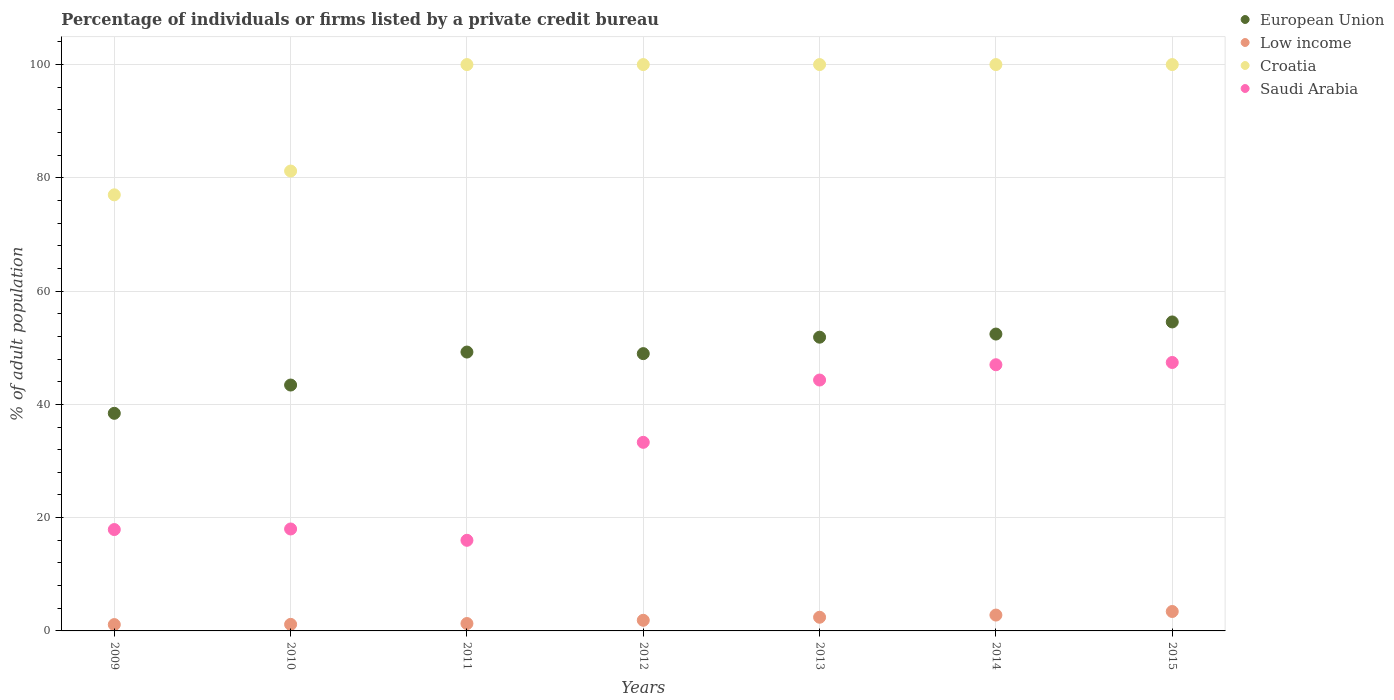What is the percentage of population listed by a private credit bureau in Low income in 2012?
Give a very brief answer. 1.88. Across all years, what is the maximum percentage of population listed by a private credit bureau in European Union?
Your answer should be compact. 54.56. Across all years, what is the minimum percentage of population listed by a private credit bureau in Croatia?
Your response must be concise. 77. In which year was the percentage of population listed by a private credit bureau in Low income maximum?
Your answer should be compact. 2015. What is the total percentage of population listed by a private credit bureau in Low income in the graph?
Keep it short and to the point. 14.1. What is the difference between the percentage of population listed by a private credit bureau in Croatia in 2010 and that in 2012?
Offer a terse response. -18.8. What is the difference between the percentage of population listed by a private credit bureau in European Union in 2013 and the percentage of population listed by a private credit bureau in Saudi Arabia in 2012?
Your answer should be very brief. 18.56. What is the average percentage of population listed by a private credit bureau in Low income per year?
Offer a terse response. 2.01. In the year 2012, what is the difference between the percentage of population listed by a private credit bureau in European Union and percentage of population listed by a private credit bureau in Low income?
Give a very brief answer. 47.08. What is the ratio of the percentage of population listed by a private credit bureau in Croatia in 2009 to that in 2015?
Offer a terse response. 0.77. Is the percentage of population listed by a private credit bureau in Croatia in 2009 less than that in 2013?
Provide a short and direct response. Yes. Is the difference between the percentage of population listed by a private credit bureau in European Union in 2010 and 2011 greater than the difference between the percentage of population listed by a private credit bureau in Low income in 2010 and 2011?
Ensure brevity in your answer.  No. What is the difference between the highest and the lowest percentage of population listed by a private credit bureau in European Union?
Provide a succinct answer. 16.13. In how many years, is the percentage of population listed by a private credit bureau in Saudi Arabia greater than the average percentage of population listed by a private credit bureau in Saudi Arabia taken over all years?
Offer a very short reply. 4. Is the sum of the percentage of population listed by a private credit bureau in Low income in 2009 and 2013 greater than the maximum percentage of population listed by a private credit bureau in European Union across all years?
Give a very brief answer. No. Is it the case that in every year, the sum of the percentage of population listed by a private credit bureau in Croatia and percentage of population listed by a private credit bureau in Low income  is greater than the sum of percentage of population listed by a private credit bureau in Saudi Arabia and percentage of population listed by a private credit bureau in European Union?
Offer a terse response. Yes. Does the percentage of population listed by a private credit bureau in Low income monotonically increase over the years?
Make the answer very short. Yes. Is the percentage of population listed by a private credit bureau in European Union strictly less than the percentage of population listed by a private credit bureau in Croatia over the years?
Ensure brevity in your answer.  Yes. How many legend labels are there?
Provide a short and direct response. 4. How are the legend labels stacked?
Provide a short and direct response. Vertical. What is the title of the graph?
Give a very brief answer. Percentage of individuals or firms listed by a private credit bureau. What is the label or title of the Y-axis?
Your answer should be compact. % of adult population. What is the % of adult population of European Union in 2009?
Give a very brief answer. 38.42. What is the % of adult population of Low income in 2009?
Offer a terse response. 1.12. What is the % of adult population of Croatia in 2009?
Give a very brief answer. 77. What is the % of adult population of Saudi Arabia in 2009?
Your answer should be compact. 17.9. What is the % of adult population of European Union in 2010?
Provide a short and direct response. 43.41. What is the % of adult population in Low income in 2010?
Offer a terse response. 1.16. What is the % of adult population of Croatia in 2010?
Your answer should be compact. 81.2. What is the % of adult population of Saudi Arabia in 2010?
Offer a very short reply. 18. What is the % of adult population in European Union in 2011?
Offer a terse response. 49.24. What is the % of adult population in Low income in 2011?
Make the answer very short. 1.3. What is the % of adult population of Saudi Arabia in 2011?
Make the answer very short. 16. What is the % of adult population in European Union in 2012?
Your answer should be compact. 48.96. What is the % of adult population in Low income in 2012?
Give a very brief answer. 1.88. What is the % of adult population of Saudi Arabia in 2012?
Your response must be concise. 33.3. What is the % of adult population of European Union in 2013?
Offer a very short reply. 51.86. What is the % of adult population in Low income in 2013?
Provide a succinct answer. 2.41. What is the % of adult population in Saudi Arabia in 2013?
Offer a terse response. 44.3. What is the % of adult population in European Union in 2014?
Ensure brevity in your answer.  52.42. What is the % of adult population in Low income in 2014?
Ensure brevity in your answer.  2.8. What is the % of adult population of Croatia in 2014?
Keep it short and to the point. 100. What is the % of adult population in Saudi Arabia in 2014?
Ensure brevity in your answer.  47. What is the % of adult population in European Union in 2015?
Offer a very short reply. 54.56. What is the % of adult population in Low income in 2015?
Your response must be concise. 3.43. What is the % of adult population in Croatia in 2015?
Make the answer very short. 100. What is the % of adult population of Saudi Arabia in 2015?
Keep it short and to the point. 47.4. Across all years, what is the maximum % of adult population in European Union?
Your answer should be very brief. 54.56. Across all years, what is the maximum % of adult population of Low income?
Provide a short and direct response. 3.43. Across all years, what is the maximum % of adult population of Saudi Arabia?
Ensure brevity in your answer.  47.4. Across all years, what is the minimum % of adult population in European Union?
Provide a succinct answer. 38.42. Across all years, what is the minimum % of adult population in Low income?
Provide a short and direct response. 1.12. Across all years, what is the minimum % of adult population in Croatia?
Provide a short and direct response. 77. What is the total % of adult population in European Union in the graph?
Keep it short and to the point. 338.88. What is the total % of adult population of Low income in the graph?
Offer a very short reply. 14.1. What is the total % of adult population in Croatia in the graph?
Ensure brevity in your answer.  658.2. What is the total % of adult population in Saudi Arabia in the graph?
Give a very brief answer. 223.9. What is the difference between the % of adult population in European Union in 2009 and that in 2010?
Offer a terse response. -4.99. What is the difference between the % of adult population in Low income in 2009 and that in 2010?
Offer a terse response. -0.04. What is the difference between the % of adult population in Croatia in 2009 and that in 2010?
Offer a very short reply. -4.2. What is the difference between the % of adult population of European Union in 2009 and that in 2011?
Your answer should be very brief. -10.82. What is the difference between the % of adult population in Low income in 2009 and that in 2011?
Offer a very short reply. -0.19. What is the difference between the % of adult population in Saudi Arabia in 2009 and that in 2011?
Offer a very short reply. 1.9. What is the difference between the % of adult population of European Union in 2009 and that in 2012?
Your answer should be very brief. -10.54. What is the difference between the % of adult population of Low income in 2009 and that in 2012?
Your response must be concise. -0.76. What is the difference between the % of adult population of Saudi Arabia in 2009 and that in 2012?
Your response must be concise. -15.4. What is the difference between the % of adult population of European Union in 2009 and that in 2013?
Provide a succinct answer. -13.44. What is the difference between the % of adult population of Low income in 2009 and that in 2013?
Your answer should be very brief. -1.3. What is the difference between the % of adult population of Croatia in 2009 and that in 2013?
Provide a short and direct response. -23. What is the difference between the % of adult population in Saudi Arabia in 2009 and that in 2013?
Offer a very short reply. -26.4. What is the difference between the % of adult population of European Union in 2009 and that in 2014?
Offer a terse response. -14. What is the difference between the % of adult population of Low income in 2009 and that in 2014?
Offer a terse response. -1.68. What is the difference between the % of adult population of Saudi Arabia in 2009 and that in 2014?
Offer a terse response. -29.1. What is the difference between the % of adult population in European Union in 2009 and that in 2015?
Give a very brief answer. -16.13. What is the difference between the % of adult population in Low income in 2009 and that in 2015?
Ensure brevity in your answer.  -2.31. What is the difference between the % of adult population in Croatia in 2009 and that in 2015?
Provide a short and direct response. -23. What is the difference between the % of adult population of Saudi Arabia in 2009 and that in 2015?
Your response must be concise. -29.5. What is the difference between the % of adult population of European Union in 2010 and that in 2011?
Offer a terse response. -5.82. What is the difference between the % of adult population of Low income in 2010 and that in 2011?
Ensure brevity in your answer.  -0.15. What is the difference between the % of adult population of Croatia in 2010 and that in 2011?
Your response must be concise. -18.8. What is the difference between the % of adult population in European Union in 2010 and that in 2012?
Your answer should be compact. -5.55. What is the difference between the % of adult population of Low income in 2010 and that in 2012?
Offer a very short reply. -0.72. What is the difference between the % of adult population in Croatia in 2010 and that in 2012?
Your answer should be very brief. -18.8. What is the difference between the % of adult population in Saudi Arabia in 2010 and that in 2012?
Provide a succinct answer. -15.3. What is the difference between the % of adult population of European Union in 2010 and that in 2013?
Your response must be concise. -8.45. What is the difference between the % of adult population in Low income in 2010 and that in 2013?
Offer a terse response. -1.26. What is the difference between the % of adult population in Croatia in 2010 and that in 2013?
Ensure brevity in your answer.  -18.8. What is the difference between the % of adult population of Saudi Arabia in 2010 and that in 2013?
Ensure brevity in your answer.  -26.3. What is the difference between the % of adult population in European Union in 2010 and that in 2014?
Offer a very short reply. -9. What is the difference between the % of adult population of Low income in 2010 and that in 2014?
Give a very brief answer. -1.64. What is the difference between the % of adult population of Croatia in 2010 and that in 2014?
Give a very brief answer. -18.8. What is the difference between the % of adult population in European Union in 2010 and that in 2015?
Ensure brevity in your answer.  -11.14. What is the difference between the % of adult population of Low income in 2010 and that in 2015?
Your response must be concise. -2.27. What is the difference between the % of adult population in Croatia in 2010 and that in 2015?
Provide a succinct answer. -18.8. What is the difference between the % of adult population of Saudi Arabia in 2010 and that in 2015?
Offer a terse response. -29.4. What is the difference between the % of adult population of European Union in 2011 and that in 2012?
Provide a succinct answer. 0.28. What is the difference between the % of adult population in Low income in 2011 and that in 2012?
Offer a terse response. -0.57. What is the difference between the % of adult population in Croatia in 2011 and that in 2012?
Offer a terse response. 0. What is the difference between the % of adult population of Saudi Arabia in 2011 and that in 2012?
Your response must be concise. -17.3. What is the difference between the % of adult population of European Union in 2011 and that in 2013?
Your answer should be very brief. -2.62. What is the difference between the % of adult population in Low income in 2011 and that in 2013?
Ensure brevity in your answer.  -1.11. What is the difference between the % of adult population in Croatia in 2011 and that in 2013?
Offer a very short reply. 0. What is the difference between the % of adult population in Saudi Arabia in 2011 and that in 2013?
Provide a short and direct response. -28.3. What is the difference between the % of adult population in European Union in 2011 and that in 2014?
Keep it short and to the point. -3.18. What is the difference between the % of adult population of Low income in 2011 and that in 2014?
Keep it short and to the point. -1.5. What is the difference between the % of adult population in Croatia in 2011 and that in 2014?
Give a very brief answer. 0. What is the difference between the % of adult population in Saudi Arabia in 2011 and that in 2014?
Provide a short and direct response. -31. What is the difference between the % of adult population of European Union in 2011 and that in 2015?
Keep it short and to the point. -5.32. What is the difference between the % of adult population in Low income in 2011 and that in 2015?
Make the answer very short. -2.13. What is the difference between the % of adult population in Saudi Arabia in 2011 and that in 2015?
Keep it short and to the point. -31.4. What is the difference between the % of adult population of European Union in 2012 and that in 2013?
Offer a terse response. -2.9. What is the difference between the % of adult population in Low income in 2012 and that in 2013?
Give a very brief answer. -0.54. What is the difference between the % of adult population in Croatia in 2012 and that in 2013?
Provide a succinct answer. 0. What is the difference between the % of adult population of European Union in 2012 and that in 2014?
Keep it short and to the point. -3.46. What is the difference between the % of adult population of Low income in 2012 and that in 2014?
Provide a succinct answer. -0.92. What is the difference between the % of adult population in Croatia in 2012 and that in 2014?
Your response must be concise. 0. What is the difference between the % of adult population in Saudi Arabia in 2012 and that in 2014?
Make the answer very short. -13.7. What is the difference between the % of adult population of European Union in 2012 and that in 2015?
Ensure brevity in your answer.  -5.6. What is the difference between the % of adult population of Low income in 2012 and that in 2015?
Offer a very short reply. -1.55. What is the difference between the % of adult population in Saudi Arabia in 2012 and that in 2015?
Your answer should be very brief. -14.1. What is the difference between the % of adult population in European Union in 2013 and that in 2014?
Ensure brevity in your answer.  -0.55. What is the difference between the % of adult population in Low income in 2013 and that in 2014?
Make the answer very short. -0.39. What is the difference between the % of adult population in Croatia in 2013 and that in 2014?
Provide a short and direct response. 0. What is the difference between the % of adult population in Saudi Arabia in 2013 and that in 2014?
Your response must be concise. -2.7. What is the difference between the % of adult population of European Union in 2013 and that in 2015?
Your answer should be very brief. -2.69. What is the difference between the % of adult population of Low income in 2013 and that in 2015?
Your answer should be very brief. -1.02. What is the difference between the % of adult population of Saudi Arabia in 2013 and that in 2015?
Your answer should be very brief. -3.1. What is the difference between the % of adult population in European Union in 2014 and that in 2015?
Your answer should be compact. -2.14. What is the difference between the % of adult population in Low income in 2014 and that in 2015?
Give a very brief answer. -0.63. What is the difference between the % of adult population in European Union in 2009 and the % of adult population in Low income in 2010?
Your answer should be compact. 37.27. What is the difference between the % of adult population in European Union in 2009 and the % of adult population in Croatia in 2010?
Keep it short and to the point. -42.78. What is the difference between the % of adult population of European Union in 2009 and the % of adult population of Saudi Arabia in 2010?
Offer a terse response. 20.42. What is the difference between the % of adult population of Low income in 2009 and the % of adult population of Croatia in 2010?
Your answer should be compact. -80.08. What is the difference between the % of adult population in Low income in 2009 and the % of adult population in Saudi Arabia in 2010?
Your response must be concise. -16.88. What is the difference between the % of adult population of European Union in 2009 and the % of adult population of Low income in 2011?
Give a very brief answer. 37.12. What is the difference between the % of adult population in European Union in 2009 and the % of adult population in Croatia in 2011?
Ensure brevity in your answer.  -61.58. What is the difference between the % of adult population in European Union in 2009 and the % of adult population in Saudi Arabia in 2011?
Your answer should be compact. 22.42. What is the difference between the % of adult population of Low income in 2009 and the % of adult population of Croatia in 2011?
Make the answer very short. -98.88. What is the difference between the % of adult population in Low income in 2009 and the % of adult population in Saudi Arabia in 2011?
Make the answer very short. -14.88. What is the difference between the % of adult population in Croatia in 2009 and the % of adult population in Saudi Arabia in 2011?
Keep it short and to the point. 61. What is the difference between the % of adult population of European Union in 2009 and the % of adult population of Low income in 2012?
Provide a short and direct response. 36.55. What is the difference between the % of adult population of European Union in 2009 and the % of adult population of Croatia in 2012?
Your answer should be very brief. -61.58. What is the difference between the % of adult population in European Union in 2009 and the % of adult population in Saudi Arabia in 2012?
Your answer should be compact. 5.12. What is the difference between the % of adult population of Low income in 2009 and the % of adult population of Croatia in 2012?
Your answer should be very brief. -98.88. What is the difference between the % of adult population in Low income in 2009 and the % of adult population in Saudi Arabia in 2012?
Your answer should be very brief. -32.18. What is the difference between the % of adult population in Croatia in 2009 and the % of adult population in Saudi Arabia in 2012?
Provide a succinct answer. 43.7. What is the difference between the % of adult population of European Union in 2009 and the % of adult population of Low income in 2013?
Provide a succinct answer. 36.01. What is the difference between the % of adult population of European Union in 2009 and the % of adult population of Croatia in 2013?
Give a very brief answer. -61.58. What is the difference between the % of adult population of European Union in 2009 and the % of adult population of Saudi Arabia in 2013?
Your answer should be very brief. -5.88. What is the difference between the % of adult population of Low income in 2009 and the % of adult population of Croatia in 2013?
Provide a succinct answer. -98.88. What is the difference between the % of adult population in Low income in 2009 and the % of adult population in Saudi Arabia in 2013?
Offer a terse response. -43.18. What is the difference between the % of adult population in Croatia in 2009 and the % of adult population in Saudi Arabia in 2013?
Ensure brevity in your answer.  32.7. What is the difference between the % of adult population of European Union in 2009 and the % of adult population of Low income in 2014?
Your answer should be compact. 35.62. What is the difference between the % of adult population in European Union in 2009 and the % of adult population in Croatia in 2014?
Provide a succinct answer. -61.58. What is the difference between the % of adult population of European Union in 2009 and the % of adult population of Saudi Arabia in 2014?
Offer a very short reply. -8.58. What is the difference between the % of adult population of Low income in 2009 and the % of adult population of Croatia in 2014?
Offer a terse response. -98.88. What is the difference between the % of adult population in Low income in 2009 and the % of adult population in Saudi Arabia in 2014?
Your answer should be very brief. -45.88. What is the difference between the % of adult population of European Union in 2009 and the % of adult population of Low income in 2015?
Your answer should be compact. 34.99. What is the difference between the % of adult population of European Union in 2009 and the % of adult population of Croatia in 2015?
Offer a very short reply. -61.58. What is the difference between the % of adult population of European Union in 2009 and the % of adult population of Saudi Arabia in 2015?
Provide a succinct answer. -8.98. What is the difference between the % of adult population of Low income in 2009 and the % of adult population of Croatia in 2015?
Provide a succinct answer. -98.88. What is the difference between the % of adult population of Low income in 2009 and the % of adult population of Saudi Arabia in 2015?
Offer a very short reply. -46.28. What is the difference between the % of adult population in Croatia in 2009 and the % of adult population in Saudi Arabia in 2015?
Give a very brief answer. 29.6. What is the difference between the % of adult population of European Union in 2010 and the % of adult population of Low income in 2011?
Your response must be concise. 42.11. What is the difference between the % of adult population in European Union in 2010 and the % of adult population in Croatia in 2011?
Provide a succinct answer. -56.59. What is the difference between the % of adult population of European Union in 2010 and the % of adult population of Saudi Arabia in 2011?
Ensure brevity in your answer.  27.41. What is the difference between the % of adult population in Low income in 2010 and the % of adult population in Croatia in 2011?
Offer a very short reply. -98.84. What is the difference between the % of adult population in Low income in 2010 and the % of adult population in Saudi Arabia in 2011?
Provide a succinct answer. -14.84. What is the difference between the % of adult population of Croatia in 2010 and the % of adult population of Saudi Arabia in 2011?
Your response must be concise. 65.2. What is the difference between the % of adult population in European Union in 2010 and the % of adult population in Low income in 2012?
Provide a succinct answer. 41.54. What is the difference between the % of adult population of European Union in 2010 and the % of adult population of Croatia in 2012?
Provide a succinct answer. -56.59. What is the difference between the % of adult population of European Union in 2010 and the % of adult population of Saudi Arabia in 2012?
Your answer should be very brief. 10.11. What is the difference between the % of adult population of Low income in 2010 and the % of adult population of Croatia in 2012?
Offer a terse response. -98.84. What is the difference between the % of adult population in Low income in 2010 and the % of adult population in Saudi Arabia in 2012?
Provide a short and direct response. -32.14. What is the difference between the % of adult population of Croatia in 2010 and the % of adult population of Saudi Arabia in 2012?
Provide a short and direct response. 47.9. What is the difference between the % of adult population of European Union in 2010 and the % of adult population of Low income in 2013?
Your answer should be very brief. 41. What is the difference between the % of adult population in European Union in 2010 and the % of adult population in Croatia in 2013?
Your answer should be compact. -56.59. What is the difference between the % of adult population of European Union in 2010 and the % of adult population of Saudi Arabia in 2013?
Ensure brevity in your answer.  -0.89. What is the difference between the % of adult population of Low income in 2010 and the % of adult population of Croatia in 2013?
Your answer should be very brief. -98.84. What is the difference between the % of adult population of Low income in 2010 and the % of adult population of Saudi Arabia in 2013?
Provide a short and direct response. -43.14. What is the difference between the % of adult population in Croatia in 2010 and the % of adult population in Saudi Arabia in 2013?
Ensure brevity in your answer.  36.9. What is the difference between the % of adult population of European Union in 2010 and the % of adult population of Low income in 2014?
Make the answer very short. 40.62. What is the difference between the % of adult population of European Union in 2010 and the % of adult population of Croatia in 2014?
Give a very brief answer. -56.59. What is the difference between the % of adult population in European Union in 2010 and the % of adult population in Saudi Arabia in 2014?
Your answer should be very brief. -3.59. What is the difference between the % of adult population of Low income in 2010 and the % of adult population of Croatia in 2014?
Offer a very short reply. -98.84. What is the difference between the % of adult population in Low income in 2010 and the % of adult population in Saudi Arabia in 2014?
Your answer should be compact. -45.84. What is the difference between the % of adult population of Croatia in 2010 and the % of adult population of Saudi Arabia in 2014?
Keep it short and to the point. 34.2. What is the difference between the % of adult population of European Union in 2010 and the % of adult population of Low income in 2015?
Keep it short and to the point. 39.98. What is the difference between the % of adult population in European Union in 2010 and the % of adult population in Croatia in 2015?
Keep it short and to the point. -56.59. What is the difference between the % of adult population in European Union in 2010 and the % of adult population in Saudi Arabia in 2015?
Give a very brief answer. -3.99. What is the difference between the % of adult population in Low income in 2010 and the % of adult population in Croatia in 2015?
Offer a terse response. -98.84. What is the difference between the % of adult population of Low income in 2010 and the % of adult population of Saudi Arabia in 2015?
Make the answer very short. -46.24. What is the difference between the % of adult population in Croatia in 2010 and the % of adult population in Saudi Arabia in 2015?
Offer a very short reply. 33.8. What is the difference between the % of adult population in European Union in 2011 and the % of adult population in Low income in 2012?
Give a very brief answer. 47.36. What is the difference between the % of adult population in European Union in 2011 and the % of adult population in Croatia in 2012?
Offer a terse response. -50.76. What is the difference between the % of adult population in European Union in 2011 and the % of adult population in Saudi Arabia in 2012?
Your answer should be very brief. 15.94. What is the difference between the % of adult population in Low income in 2011 and the % of adult population in Croatia in 2012?
Ensure brevity in your answer.  -98.7. What is the difference between the % of adult population in Low income in 2011 and the % of adult population in Saudi Arabia in 2012?
Offer a very short reply. -32. What is the difference between the % of adult population in Croatia in 2011 and the % of adult population in Saudi Arabia in 2012?
Offer a terse response. 66.7. What is the difference between the % of adult population of European Union in 2011 and the % of adult population of Low income in 2013?
Offer a terse response. 46.83. What is the difference between the % of adult population of European Union in 2011 and the % of adult population of Croatia in 2013?
Offer a very short reply. -50.76. What is the difference between the % of adult population in European Union in 2011 and the % of adult population in Saudi Arabia in 2013?
Keep it short and to the point. 4.94. What is the difference between the % of adult population in Low income in 2011 and the % of adult population in Croatia in 2013?
Offer a terse response. -98.7. What is the difference between the % of adult population in Low income in 2011 and the % of adult population in Saudi Arabia in 2013?
Offer a very short reply. -43. What is the difference between the % of adult population of Croatia in 2011 and the % of adult population of Saudi Arabia in 2013?
Your answer should be very brief. 55.7. What is the difference between the % of adult population in European Union in 2011 and the % of adult population in Low income in 2014?
Give a very brief answer. 46.44. What is the difference between the % of adult population in European Union in 2011 and the % of adult population in Croatia in 2014?
Offer a very short reply. -50.76. What is the difference between the % of adult population in European Union in 2011 and the % of adult population in Saudi Arabia in 2014?
Make the answer very short. 2.24. What is the difference between the % of adult population in Low income in 2011 and the % of adult population in Croatia in 2014?
Provide a succinct answer. -98.7. What is the difference between the % of adult population of Low income in 2011 and the % of adult population of Saudi Arabia in 2014?
Your answer should be very brief. -45.7. What is the difference between the % of adult population of Croatia in 2011 and the % of adult population of Saudi Arabia in 2014?
Ensure brevity in your answer.  53. What is the difference between the % of adult population in European Union in 2011 and the % of adult population in Low income in 2015?
Your answer should be compact. 45.81. What is the difference between the % of adult population in European Union in 2011 and the % of adult population in Croatia in 2015?
Make the answer very short. -50.76. What is the difference between the % of adult population of European Union in 2011 and the % of adult population of Saudi Arabia in 2015?
Ensure brevity in your answer.  1.84. What is the difference between the % of adult population in Low income in 2011 and the % of adult population in Croatia in 2015?
Give a very brief answer. -98.7. What is the difference between the % of adult population of Low income in 2011 and the % of adult population of Saudi Arabia in 2015?
Keep it short and to the point. -46.1. What is the difference between the % of adult population of Croatia in 2011 and the % of adult population of Saudi Arabia in 2015?
Offer a terse response. 52.6. What is the difference between the % of adult population in European Union in 2012 and the % of adult population in Low income in 2013?
Provide a succinct answer. 46.55. What is the difference between the % of adult population of European Union in 2012 and the % of adult population of Croatia in 2013?
Provide a short and direct response. -51.04. What is the difference between the % of adult population in European Union in 2012 and the % of adult population in Saudi Arabia in 2013?
Give a very brief answer. 4.66. What is the difference between the % of adult population in Low income in 2012 and the % of adult population in Croatia in 2013?
Ensure brevity in your answer.  -98.12. What is the difference between the % of adult population of Low income in 2012 and the % of adult population of Saudi Arabia in 2013?
Ensure brevity in your answer.  -42.42. What is the difference between the % of adult population in Croatia in 2012 and the % of adult population in Saudi Arabia in 2013?
Offer a very short reply. 55.7. What is the difference between the % of adult population of European Union in 2012 and the % of adult population of Low income in 2014?
Ensure brevity in your answer.  46.16. What is the difference between the % of adult population of European Union in 2012 and the % of adult population of Croatia in 2014?
Keep it short and to the point. -51.04. What is the difference between the % of adult population of European Union in 2012 and the % of adult population of Saudi Arabia in 2014?
Provide a short and direct response. 1.96. What is the difference between the % of adult population of Low income in 2012 and the % of adult population of Croatia in 2014?
Provide a succinct answer. -98.12. What is the difference between the % of adult population of Low income in 2012 and the % of adult population of Saudi Arabia in 2014?
Offer a terse response. -45.12. What is the difference between the % of adult population of European Union in 2012 and the % of adult population of Low income in 2015?
Your answer should be compact. 45.53. What is the difference between the % of adult population of European Union in 2012 and the % of adult population of Croatia in 2015?
Provide a succinct answer. -51.04. What is the difference between the % of adult population in European Union in 2012 and the % of adult population in Saudi Arabia in 2015?
Provide a succinct answer. 1.56. What is the difference between the % of adult population of Low income in 2012 and the % of adult population of Croatia in 2015?
Your response must be concise. -98.12. What is the difference between the % of adult population in Low income in 2012 and the % of adult population in Saudi Arabia in 2015?
Keep it short and to the point. -45.52. What is the difference between the % of adult population in Croatia in 2012 and the % of adult population in Saudi Arabia in 2015?
Offer a very short reply. 52.6. What is the difference between the % of adult population in European Union in 2013 and the % of adult population in Low income in 2014?
Provide a short and direct response. 49.06. What is the difference between the % of adult population in European Union in 2013 and the % of adult population in Croatia in 2014?
Give a very brief answer. -48.14. What is the difference between the % of adult population of European Union in 2013 and the % of adult population of Saudi Arabia in 2014?
Your answer should be very brief. 4.86. What is the difference between the % of adult population of Low income in 2013 and the % of adult population of Croatia in 2014?
Offer a terse response. -97.59. What is the difference between the % of adult population in Low income in 2013 and the % of adult population in Saudi Arabia in 2014?
Ensure brevity in your answer.  -44.59. What is the difference between the % of adult population in Croatia in 2013 and the % of adult population in Saudi Arabia in 2014?
Ensure brevity in your answer.  53. What is the difference between the % of adult population of European Union in 2013 and the % of adult population of Low income in 2015?
Provide a short and direct response. 48.43. What is the difference between the % of adult population in European Union in 2013 and the % of adult population in Croatia in 2015?
Your answer should be compact. -48.14. What is the difference between the % of adult population in European Union in 2013 and the % of adult population in Saudi Arabia in 2015?
Offer a terse response. 4.46. What is the difference between the % of adult population of Low income in 2013 and the % of adult population of Croatia in 2015?
Provide a short and direct response. -97.59. What is the difference between the % of adult population of Low income in 2013 and the % of adult population of Saudi Arabia in 2015?
Keep it short and to the point. -44.99. What is the difference between the % of adult population in Croatia in 2013 and the % of adult population in Saudi Arabia in 2015?
Keep it short and to the point. 52.6. What is the difference between the % of adult population of European Union in 2014 and the % of adult population of Low income in 2015?
Ensure brevity in your answer.  48.99. What is the difference between the % of adult population in European Union in 2014 and the % of adult population in Croatia in 2015?
Your response must be concise. -47.58. What is the difference between the % of adult population of European Union in 2014 and the % of adult population of Saudi Arabia in 2015?
Ensure brevity in your answer.  5.02. What is the difference between the % of adult population in Low income in 2014 and the % of adult population in Croatia in 2015?
Give a very brief answer. -97.2. What is the difference between the % of adult population of Low income in 2014 and the % of adult population of Saudi Arabia in 2015?
Offer a very short reply. -44.6. What is the difference between the % of adult population of Croatia in 2014 and the % of adult population of Saudi Arabia in 2015?
Your answer should be compact. 52.6. What is the average % of adult population in European Union per year?
Your answer should be very brief. 48.41. What is the average % of adult population in Low income per year?
Your response must be concise. 2.01. What is the average % of adult population in Croatia per year?
Give a very brief answer. 94.03. What is the average % of adult population in Saudi Arabia per year?
Your response must be concise. 31.99. In the year 2009, what is the difference between the % of adult population of European Union and % of adult population of Low income?
Your answer should be very brief. 37.3. In the year 2009, what is the difference between the % of adult population in European Union and % of adult population in Croatia?
Provide a short and direct response. -38.58. In the year 2009, what is the difference between the % of adult population of European Union and % of adult population of Saudi Arabia?
Keep it short and to the point. 20.52. In the year 2009, what is the difference between the % of adult population of Low income and % of adult population of Croatia?
Provide a succinct answer. -75.88. In the year 2009, what is the difference between the % of adult population of Low income and % of adult population of Saudi Arabia?
Give a very brief answer. -16.78. In the year 2009, what is the difference between the % of adult population in Croatia and % of adult population in Saudi Arabia?
Provide a short and direct response. 59.1. In the year 2010, what is the difference between the % of adult population in European Union and % of adult population in Low income?
Your answer should be compact. 42.26. In the year 2010, what is the difference between the % of adult population in European Union and % of adult population in Croatia?
Keep it short and to the point. -37.79. In the year 2010, what is the difference between the % of adult population in European Union and % of adult population in Saudi Arabia?
Keep it short and to the point. 25.41. In the year 2010, what is the difference between the % of adult population in Low income and % of adult population in Croatia?
Make the answer very short. -80.04. In the year 2010, what is the difference between the % of adult population of Low income and % of adult population of Saudi Arabia?
Make the answer very short. -16.84. In the year 2010, what is the difference between the % of adult population of Croatia and % of adult population of Saudi Arabia?
Offer a terse response. 63.2. In the year 2011, what is the difference between the % of adult population of European Union and % of adult population of Low income?
Offer a terse response. 47.94. In the year 2011, what is the difference between the % of adult population in European Union and % of adult population in Croatia?
Offer a very short reply. -50.76. In the year 2011, what is the difference between the % of adult population of European Union and % of adult population of Saudi Arabia?
Ensure brevity in your answer.  33.24. In the year 2011, what is the difference between the % of adult population in Low income and % of adult population in Croatia?
Ensure brevity in your answer.  -98.7. In the year 2011, what is the difference between the % of adult population of Low income and % of adult population of Saudi Arabia?
Your answer should be compact. -14.7. In the year 2012, what is the difference between the % of adult population of European Union and % of adult population of Low income?
Ensure brevity in your answer.  47.08. In the year 2012, what is the difference between the % of adult population in European Union and % of adult population in Croatia?
Offer a very short reply. -51.04. In the year 2012, what is the difference between the % of adult population in European Union and % of adult population in Saudi Arabia?
Offer a terse response. 15.66. In the year 2012, what is the difference between the % of adult population of Low income and % of adult population of Croatia?
Ensure brevity in your answer.  -98.12. In the year 2012, what is the difference between the % of adult population of Low income and % of adult population of Saudi Arabia?
Give a very brief answer. -31.42. In the year 2012, what is the difference between the % of adult population of Croatia and % of adult population of Saudi Arabia?
Offer a terse response. 66.7. In the year 2013, what is the difference between the % of adult population of European Union and % of adult population of Low income?
Ensure brevity in your answer.  49.45. In the year 2013, what is the difference between the % of adult population of European Union and % of adult population of Croatia?
Give a very brief answer. -48.14. In the year 2013, what is the difference between the % of adult population of European Union and % of adult population of Saudi Arabia?
Your answer should be compact. 7.56. In the year 2013, what is the difference between the % of adult population of Low income and % of adult population of Croatia?
Your answer should be very brief. -97.59. In the year 2013, what is the difference between the % of adult population in Low income and % of adult population in Saudi Arabia?
Offer a very short reply. -41.89. In the year 2013, what is the difference between the % of adult population in Croatia and % of adult population in Saudi Arabia?
Your answer should be very brief. 55.7. In the year 2014, what is the difference between the % of adult population of European Union and % of adult population of Low income?
Keep it short and to the point. 49.62. In the year 2014, what is the difference between the % of adult population in European Union and % of adult population in Croatia?
Offer a very short reply. -47.58. In the year 2014, what is the difference between the % of adult population in European Union and % of adult population in Saudi Arabia?
Your answer should be very brief. 5.42. In the year 2014, what is the difference between the % of adult population in Low income and % of adult population in Croatia?
Provide a succinct answer. -97.2. In the year 2014, what is the difference between the % of adult population in Low income and % of adult population in Saudi Arabia?
Your response must be concise. -44.2. In the year 2015, what is the difference between the % of adult population of European Union and % of adult population of Low income?
Give a very brief answer. 51.13. In the year 2015, what is the difference between the % of adult population of European Union and % of adult population of Croatia?
Your answer should be very brief. -45.44. In the year 2015, what is the difference between the % of adult population of European Union and % of adult population of Saudi Arabia?
Your response must be concise. 7.16. In the year 2015, what is the difference between the % of adult population in Low income and % of adult population in Croatia?
Offer a very short reply. -96.57. In the year 2015, what is the difference between the % of adult population in Low income and % of adult population in Saudi Arabia?
Your response must be concise. -43.97. In the year 2015, what is the difference between the % of adult population in Croatia and % of adult population in Saudi Arabia?
Provide a succinct answer. 52.6. What is the ratio of the % of adult population in European Union in 2009 to that in 2010?
Give a very brief answer. 0.89. What is the ratio of the % of adult population in Croatia in 2009 to that in 2010?
Your response must be concise. 0.95. What is the ratio of the % of adult population in Saudi Arabia in 2009 to that in 2010?
Ensure brevity in your answer.  0.99. What is the ratio of the % of adult population in European Union in 2009 to that in 2011?
Give a very brief answer. 0.78. What is the ratio of the % of adult population of Low income in 2009 to that in 2011?
Provide a short and direct response. 0.86. What is the ratio of the % of adult population in Croatia in 2009 to that in 2011?
Your answer should be compact. 0.77. What is the ratio of the % of adult population in Saudi Arabia in 2009 to that in 2011?
Provide a short and direct response. 1.12. What is the ratio of the % of adult population in European Union in 2009 to that in 2012?
Your response must be concise. 0.78. What is the ratio of the % of adult population in Low income in 2009 to that in 2012?
Keep it short and to the point. 0.6. What is the ratio of the % of adult population in Croatia in 2009 to that in 2012?
Provide a succinct answer. 0.77. What is the ratio of the % of adult population of Saudi Arabia in 2009 to that in 2012?
Keep it short and to the point. 0.54. What is the ratio of the % of adult population in European Union in 2009 to that in 2013?
Keep it short and to the point. 0.74. What is the ratio of the % of adult population of Low income in 2009 to that in 2013?
Offer a terse response. 0.46. What is the ratio of the % of adult population of Croatia in 2009 to that in 2013?
Give a very brief answer. 0.77. What is the ratio of the % of adult population of Saudi Arabia in 2009 to that in 2013?
Your response must be concise. 0.4. What is the ratio of the % of adult population of European Union in 2009 to that in 2014?
Give a very brief answer. 0.73. What is the ratio of the % of adult population in Low income in 2009 to that in 2014?
Ensure brevity in your answer.  0.4. What is the ratio of the % of adult population in Croatia in 2009 to that in 2014?
Your answer should be compact. 0.77. What is the ratio of the % of adult population of Saudi Arabia in 2009 to that in 2014?
Ensure brevity in your answer.  0.38. What is the ratio of the % of adult population of European Union in 2009 to that in 2015?
Your answer should be compact. 0.7. What is the ratio of the % of adult population in Low income in 2009 to that in 2015?
Your answer should be compact. 0.33. What is the ratio of the % of adult population in Croatia in 2009 to that in 2015?
Provide a short and direct response. 0.77. What is the ratio of the % of adult population of Saudi Arabia in 2009 to that in 2015?
Ensure brevity in your answer.  0.38. What is the ratio of the % of adult population in European Union in 2010 to that in 2011?
Ensure brevity in your answer.  0.88. What is the ratio of the % of adult population in Low income in 2010 to that in 2011?
Your answer should be compact. 0.89. What is the ratio of the % of adult population of Croatia in 2010 to that in 2011?
Give a very brief answer. 0.81. What is the ratio of the % of adult population in Saudi Arabia in 2010 to that in 2011?
Your answer should be compact. 1.12. What is the ratio of the % of adult population of European Union in 2010 to that in 2012?
Offer a terse response. 0.89. What is the ratio of the % of adult population of Low income in 2010 to that in 2012?
Provide a short and direct response. 0.62. What is the ratio of the % of adult population in Croatia in 2010 to that in 2012?
Your response must be concise. 0.81. What is the ratio of the % of adult population in Saudi Arabia in 2010 to that in 2012?
Your answer should be very brief. 0.54. What is the ratio of the % of adult population in European Union in 2010 to that in 2013?
Your answer should be very brief. 0.84. What is the ratio of the % of adult population in Low income in 2010 to that in 2013?
Provide a short and direct response. 0.48. What is the ratio of the % of adult population in Croatia in 2010 to that in 2013?
Your answer should be compact. 0.81. What is the ratio of the % of adult population in Saudi Arabia in 2010 to that in 2013?
Provide a short and direct response. 0.41. What is the ratio of the % of adult population in European Union in 2010 to that in 2014?
Offer a terse response. 0.83. What is the ratio of the % of adult population in Low income in 2010 to that in 2014?
Offer a very short reply. 0.41. What is the ratio of the % of adult population in Croatia in 2010 to that in 2014?
Provide a short and direct response. 0.81. What is the ratio of the % of adult population in Saudi Arabia in 2010 to that in 2014?
Provide a succinct answer. 0.38. What is the ratio of the % of adult population in European Union in 2010 to that in 2015?
Keep it short and to the point. 0.8. What is the ratio of the % of adult population in Low income in 2010 to that in 2015?
Give a very brief answer. 0.34. What is the ratio of the % of adult population in Croatia in 2010 to that in 2015?
Offer a very short reply. 0.81. What is the ratio of the % of adult population in Saudi Arabia in 2010 to that in 2015?
Provide a short and direct response. 0.38. What is the ratio of the % of adult population in European Union in 2011 to that in 2012?
Your response must be concise. 1.01. What is the ratio of the % of adult population of Low income in 2011 to that in 2012?
Keep it short and to the point. 0.69. What is the ratio of the % of adult population of Saudi Arabia in 2011 to that in 2012?
Your answer should be very brief. 0.48. What is the ratio of the % of adult population of European Union in 2011 to that in 2013?
Keep it short and to the point. 0.95. What is the ratio of the % of adult population in Low income in 2011 to that in 2013?
Your answer should be compact. 0.54. What is the ratio of the % of adult population of Croatia in 2011 to that in 2013?
Provide a succinct answer. 1. What is the ratio of the % of adult population in Saudi Arabia in 2011 to that in 2013?
Offer a very short reply. 0.36. What is the ratio of the % of adult population in European Union in 2011 to that in 2014?
Your answer should be very brief. 0.94. What is the ratio of the % of adult population in Low income in 2011 to that in 2014?
Your answer should be compact. 0.47. What is the ratio of the % of adult population in Saudi Arabia in 2011 to that in 2014?
Keep it short and to the point. 0.34. What is the ratio of the % of adult population of European Union in 2011 to that in 2015?
Provide a succinct answer. 0.9. What is the ratio of the % of adult population in Low income in 2011 to that in 2015?
Ensure brevity in your answer.  0.38. What is the ratio of the % of adult population of Croatia in 2011 to that in 2015?
Provide a short and direct response. 1. What is the ratio of the % of adult population of Saudi Arabia in 2011 to that in 2015?
Your answer should be very brief. 0.34. What is the ratio of the % of adult population of European Union in 2012 to that in 2013?
Your response must be concise. 0.94. What is the ratio of the % of adult population of Low income in 2012 to that in 2013?
Make the answer very short. 0.78. What is the ratio of the % of adult population in Croatia in 2012 to that in 2013?
Offer a very short reply. 1. What is the ratio of the % of adult population in Saudi Arabia in 2012 to that in 2013?
Offer a terse response. 0.75. What is the ratio of the % of adult population of European Union in 2012 to that in 2014?
Give a very brief answer. 0.93. What is the ratio of the % of adult population of Low income in 2012 to that in 2014?
Your answer should be compact. 0.67. What is the ratio of the % of adult population in Saudi Arabia in 2012 to that in 2014?
Provide a short and direct response. 0.71. What is the ratio of the % of adult population of European Union in 2012 to that in 2015?
Offer a very short reply. 0.9. What is the ratio of the % of adult population in Low income in 2012 to that in 2015?
Offer a very short reply. 0.55. What is the ratio of the % of adult population in Saudi Arabia in 2012 to that in 2015?
Give a very brief answer. 0.7. What is the ratio of the % of adult population of European Union in 2013 to that in 2014?
Your response must be concise. 0.99. What is the ratio of the % of adult population of Low income in 2013 to that in 2014?
Offer a very short reply. 0.86. What is the ratio of the % of adult population in Croatia in 2013 to that in 2014?
Ensure brevity in your answer.  1. What is the ratio of the % of adult population of Saudi Arabia in 2013 to that in 2014?
Provide a short and direct response. 0.94. What is the ratio of the % of adult population of European Union in 2013 to that in 2015?
Provide a succinct answer. 0.95. What is the ratio of the % of adult population in Low income in 2013 to that in 2015?
Keep it short and to the point. 0.7. What is the ratio of the % of adult population of Croatia in 2013 to that in 2015?
Provide a succinct answer. 1. What is the ratio of the % of adult population of Saudi Arabia in 2013 to that in 2015?
Offer a terse response. 0.93. What is the ratio of the % of adult population of European Union in 2014 to that in 2015?
Your response must be concise. 0.96. What is the ratio of the % of adult population of Low income in 2014 to that in 2015?
Offer a very short reply. 0.82. What is the ratio of the % of adult population in Saudi Arabia in 2014 to that in 2015?
Provide a short and direct response. 0.99. What is the difference between the highest and the second highest % of adult population of European Union?
Offer a very short reply. 2.14. What is the difference between the highest and the second highest % of adult population of Low income?
Make the answer very short. 0.63. What is the difference between the highest and the lowest % of adult population in European Union?
Give a very brief answer. 16.13. What is the difference between the highest and the lowest % of adult population of Low income?
Ensure brevity in your answer.  2.31. What is the difference between the highest and the lowest % of adult population in Croatia?
Offer a very short reply. 23. What is the difference between the highest and the lowest % of adult population in Saudi Arabia?
Provide a short and direct response. 31.4. 